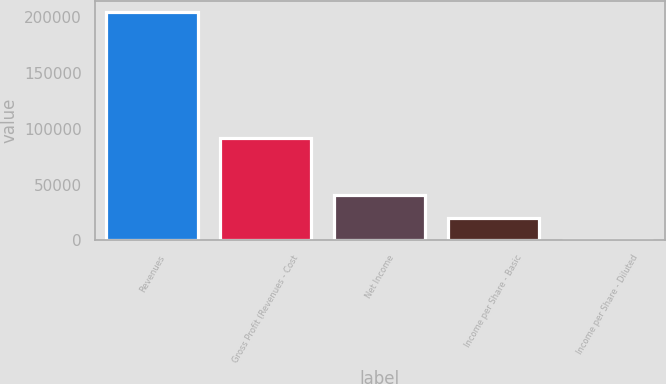Convert chart. <chart><loc_0><loc_0><loc_500><loc_500><bar_chart><fcel>Revenues<fcel>Gross Profit (Revenues - Cost<fcel>Net Income<fcel>Income per Share - Basic<fcel>Income per Share - Diluted<nl><fcel>204653<fcel>92039<fcel>40930.7<fcel>20465.4<fcel>0.15<nl></chart> 